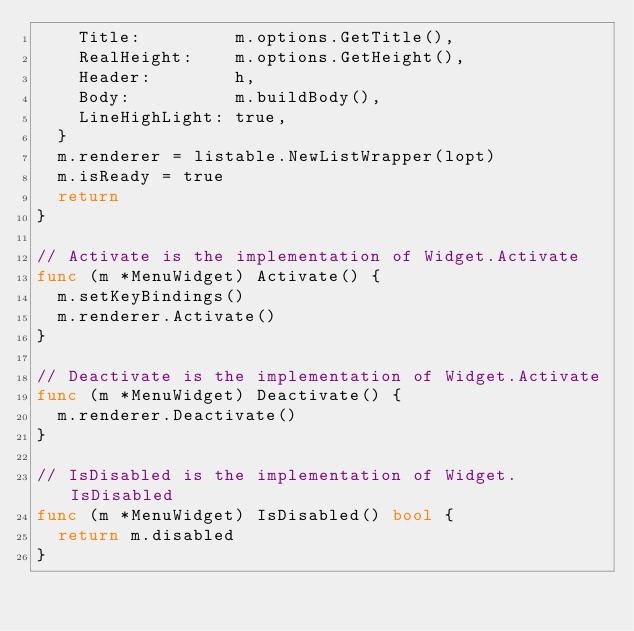<code> <loc_0><loc_0><loc_500><loc_500><_Go_>		Title:         m.options.GetTitle(),
		RealHeight:    m.options.GetHeight(),
		Header:        h,
		Body:          m.buildBody(),
		LineHighLight: true,
	}
	m.renderer = listable.NewListWrapper(lopt)
	m.isReady = true
	return
}

// Activate is the implementation of Widget.Activate
func (m *MenuWidget) Activate() {
	m.setKeyBindings()
	m.renderer.Activate()
}

// Deactivate is the implementation of Widget.Activate
func (m *MenuWidget) Deactivate() {
	m.renderer.Deactivate()
}

// IsDisabled is the implementation of Widget.IsDisabled
func (m *MenuWidget) IsDisabled() bool {
	return m.disabled
}
</code> 